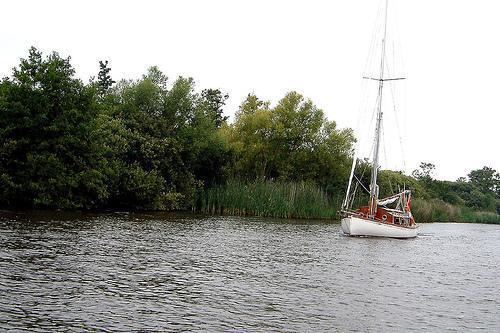How many boats?
Give a very brief answer. 1. 